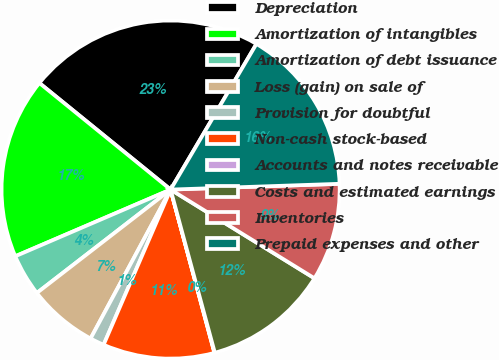<chart> <loc_0><loc_0><loc_500><loc_500><pie_chart><fcel>Depreciation<fcel>Amortization of intangibles<fcel>Amortization of debt issuance<fcel>Loss (gain) on sale of<fcel>Provision for doubtful<fcel>Non-cash stock-based<fcel>Accounts and notes receivable<fcel>Costs and estimated earnings<fcel>Inventories<fcel>Prepaid expenses and other<nl><fcel>22.62%<fcel>17.31%<fcel>4.02%<fcel>6.68%<fcel>1.36%<fcel>10.66%<fcel>0.04%<fcel>11.99%<fcel>9.34%<fcel>15.98%<nl></chart> 